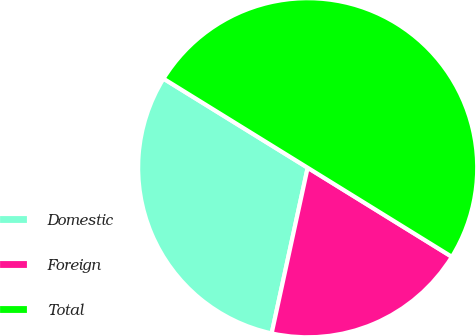<chart> <loc_0><loc_0><loc_500><loc_500><pie_chart><fcel>Domestic<fcel>Foreign<fcel>Total<nl><fcel>30.4%<fcel>19.6%<fcel>50.0%<nl></chart> 